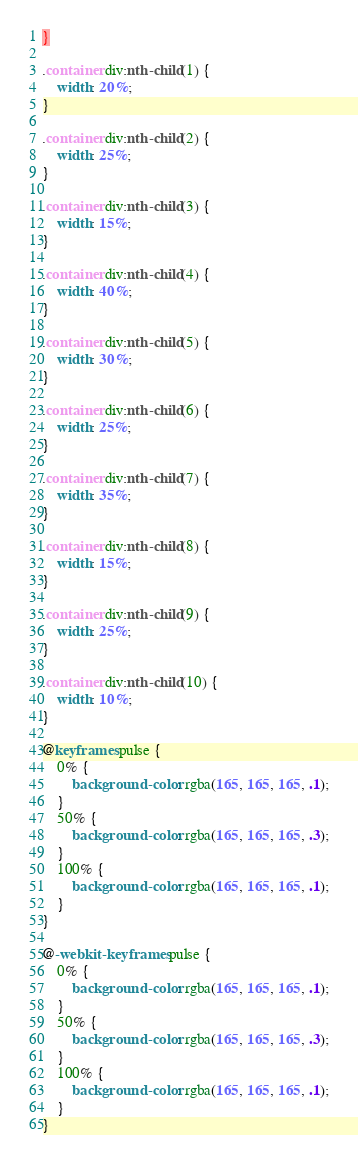<code> <loc_0><loc_0><loc_500><loc_500><_CSS_>}

.container div:nth-child(1) {
    width: 20%;
}

.container div:nth-child(2) {
    width: 25%;
}

.container div:nth-child(3) {
    width: 15%;
}

.container div:nth-child(4) {
    width: 40%;
}

.container div:nth-child(5) {
    width: 30%;
}

.container div:nth-child(6) {
    width: 25%;
}

.container div:nth-child(7) {
    width: 35%;
}

.container div:nth-child(8) {
    width: 15%;
}

.container div:nth-child(9) {
    width: 25%;
}

.container div:nth-child(10) {
    width: 10%;
}

@keyframes pulse {
    0% {
        background-color: rgba(165, 165, 165, .1);
    }
    50% {
        background-color: rgba(165, 165, 165, .3);
    }
    100% {
        background-color: rgba(165, 165, 165, .1);
    }
}

@-webkit-keyframes pulse {
    0% {
        background-color: rgba(165, 165, 165, .1);
    }
    50% {
        background-color: rgba(165, 165, 165, .3);
    }
    100% {
        background-color: rgba(165, 165, 165, .1);
    }
}</code> 